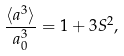<formula> <loc_0><loc_0><loc_500><loc_500>\frac { \langle a ^ { 3 } \rangle } { a _ { 0 } ^ { 3 } } = 1 + 3 S ^ { 2 } ,</formula> 